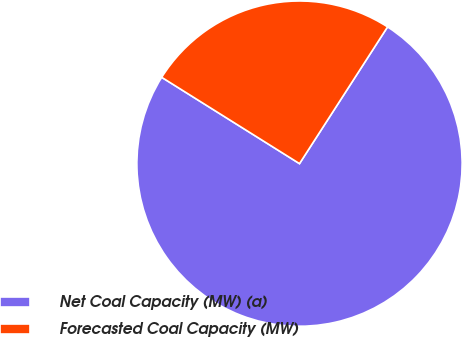Convert chart. <chart><loc_0><loc_0><loc_500><loc_500><pie_chart><fcel>Net Coal Capacity (MW) (a)<fcel>Forecasted Coal Capacity (MW)<nl><fcel>74.8%<fcel>25.2%<nl></chart> 